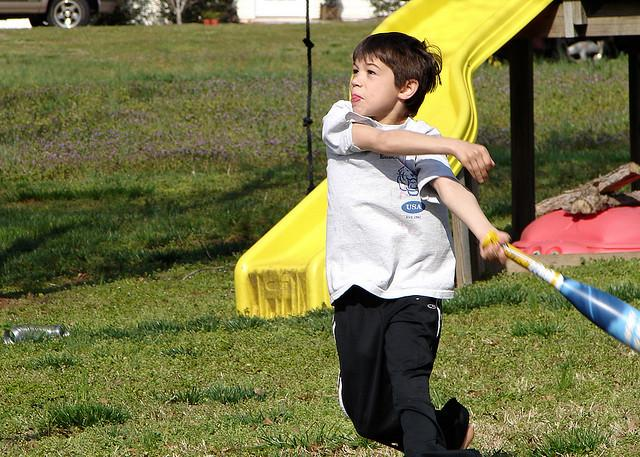What is the boy looking at?

Choices:
A) crowd
B) baseball
C) clouds
D) birds baseball 